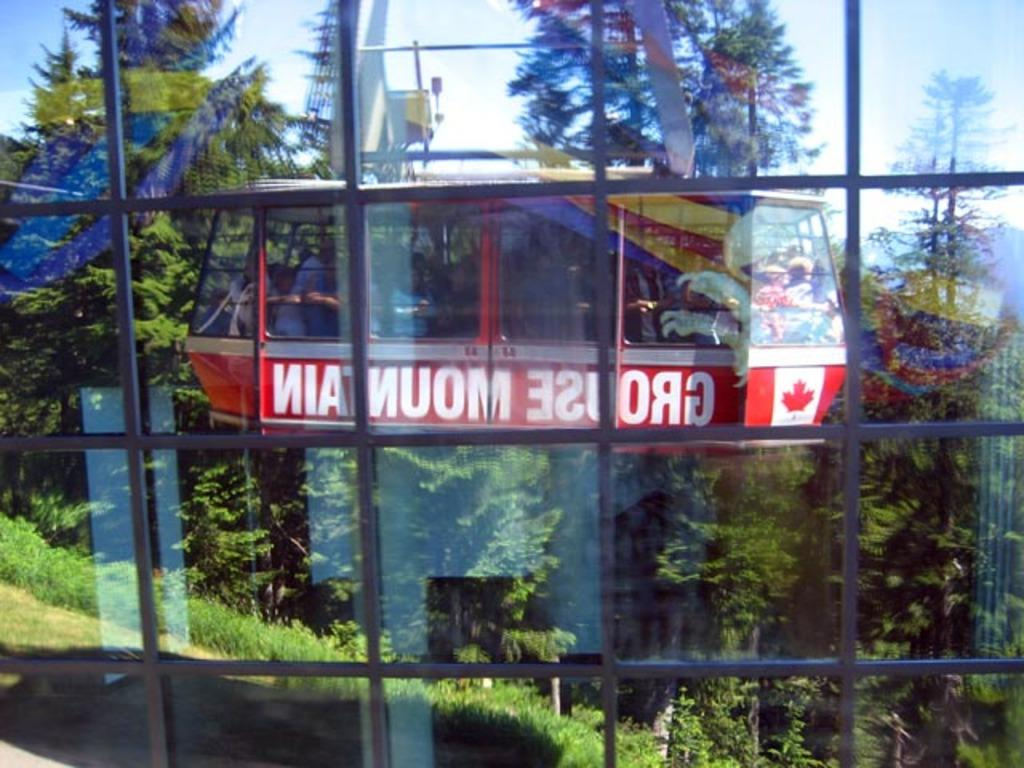<image>
Share a concise interpretation of the image provided. A gondola has a Canadian flag and the word "grouse" written backwards on it. 